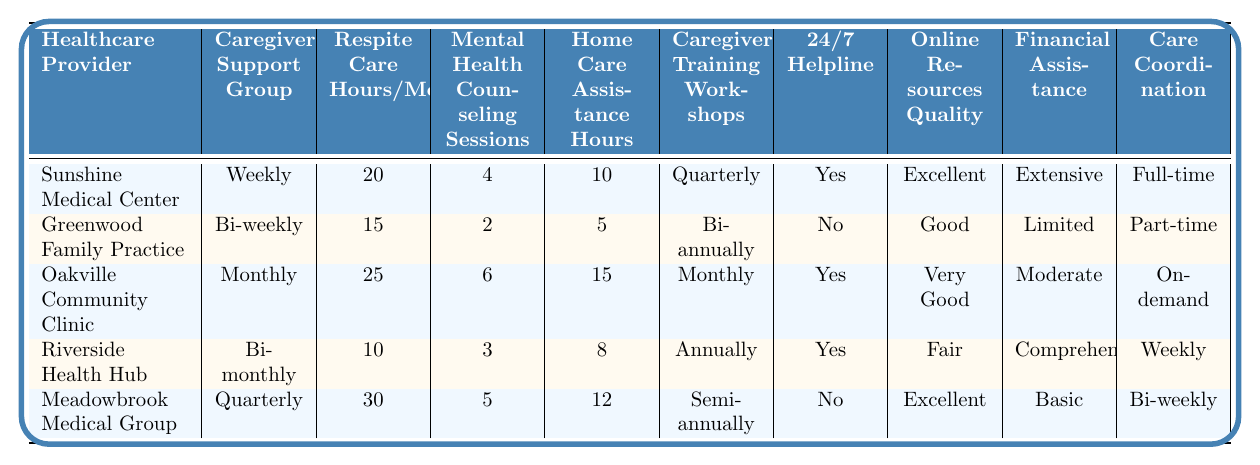What is the maximum number of respite care hours per month offered by the healthcare providers? Looking at the "Respite Care Hours/Month" column, the values are 20, 15, 25, 10, and 30. The maximum value among these is 30, provided by Meadowbrook Medical Group.
Answer: 30 Which healthcare provider offers the highest number of mental health counseling sessions? In the "Mental Health Counseling Sessions" column, the values are 4, 2, 6, 3, and 5. The highest value is 6, offered by Oakville Community Clinic.
Answer: Oakville Community Clinic Does Sunshine Medical Center provide a 24/7 helpline? The "24/7 Helpline" column indicates Yes for Sunshine Medical Center.
Answer: Yes How many hours of home care assistance are provided by Riverside Health Hub? Referring to the "Home Care Assistance Hours" column, Riverside Health Hub has 8 hours listed.
Answer: 8 Which healthcare provider has the least amount of respite care hours per month? The values for "Respite Care Hours/Month" are 20, 15, 25, 10, and 30. The least amount is 10 hours from Riverside Health Hub.
Answer: Riverside Health Hub What is the difference in mental health counseling sessions between Oakville Community Clinic and Greenwood Family Practice? Oakville Community Clinic has 6 sessions and Greenwood Family Practice has 2 sessions. Therefore, the difference is 6 - 2 = 4 sessions.
Answer: 4 Which two providers have a bi-weekly caregiver support group? Looking at the "Caregiver Support Group" column, Greenwood Family Practice and Meadowbrook Medical Group both provide bi-weekly support groups.
Answer: Greenwood Family Practice, Meadowbrook Medical Group How many total home care assistance hours do all providers offer combined? Summing up the "Home Care Assistance Hours": 10 + 5 + 15 + 8 + 12 = 50 hours.
Answer: 50 Which provider has both an excellent rating for online resources and extensive financial assistance programs? Checking the "Online Resources Quality" and "Financial Assistance" columns, Sunshine Medical Center has "Excellent" for online resources and "Extensive" for financial assistance.
Answer: Sunshine Medical Center What percentage of the providers offer a 24/7 helpline? Three out of five providers (Sunshine Medical Center, Oakville Community Clinic, and Riverside Health Hub) offer a 24/7 helpline, which gives us a percentage of (3/5) * 100 = 60%.
Answer: 60% 